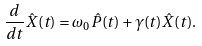Convert formula to latex. <formula><loc_0><loc_0><loc_500><loc_500>\frac { d } { d t } \hat { X } ( t ) = \omega _ { 0 } \hat { P } ( t ) + \gamma ( t ) \hat { X } ( t ) .</formula> 